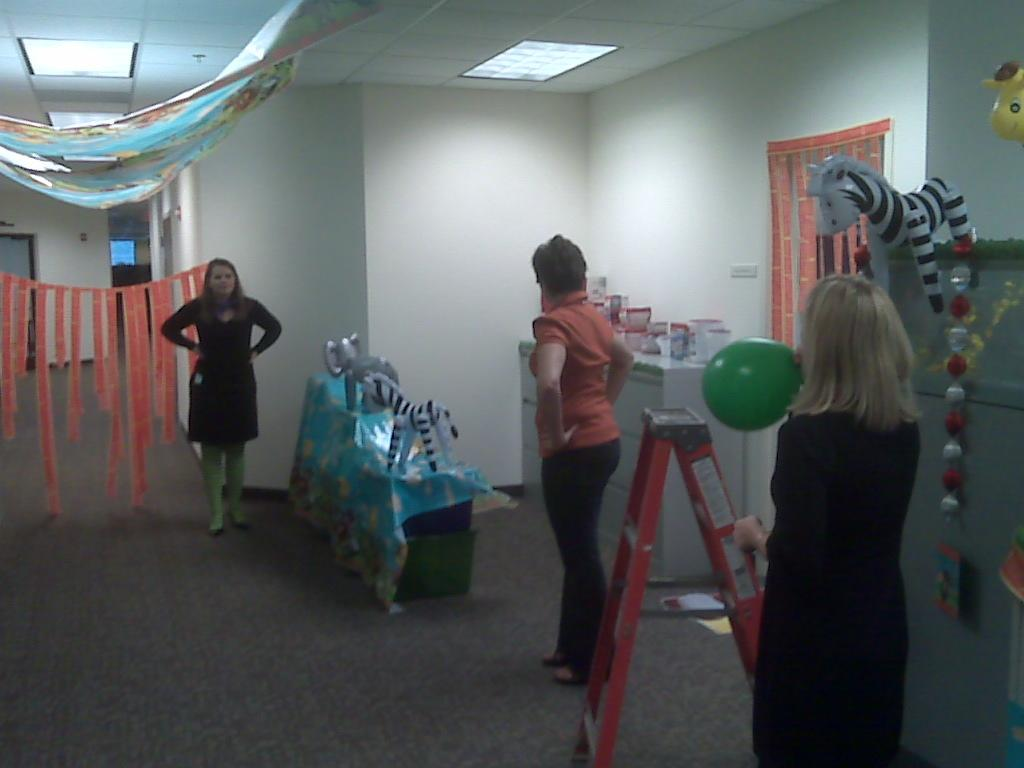Who or what can be seen in the image? There are people in the image. What else is present in the image besides people? There are toys, a stand, decorative items, a wall, a floor, objects, and lights in the image. Can you describe the stand in the image? The stand is a structure that holds or displays items. What type of decorative items are present in the image? The decorative items in the image are not specified, but they add visual interest to the scene. How many bells can be seen hanging from the chain in the image? There is no chain or bell present in the image. What type of geese are depicted on the wall in the image? There are no geese depicted on the wall in the image. 